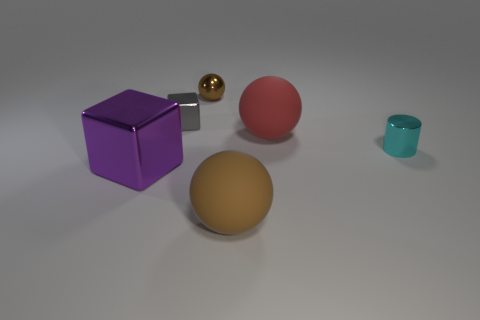Are there an equal number of metallic balls that are in front of the big metallic thing and brown spheres behind the cyan metallic thing?
Make the answer very short. No. There is a large sphere that is behind the large metallic object; what is it made of?
Your response must be concise. Rubber. Are there fewer brown objects than balls?
Give a very brief answer. Yes. There is a object that is to the left of the small shiny ball and in front of the small cylinder; what shape is it?
Provide a short and direct response. Cube. What number of small shiny cylinders are there?
Your answer should be compact. 1. There is a big object that is to the right of the rubber sphere on the left side of the large thing behind the big purple metallic thing; what is its material?
Keep it short and to the point. Rubber. There is a small object that is on the right side of the tiny brown metal thing; how many purple things are behind it?
Offer a very short reply. 0. What is the color of the other large thing that is the same shape as the big brown thing?
Provide a short and direct response. Red. Is the big purple block made of the same material as the tiny cyan cylinder?
Make the answer very short. Yes. How many balls are large gray rubber things or tiny cyan metallic objects?
Offer a very short reply. 0. 